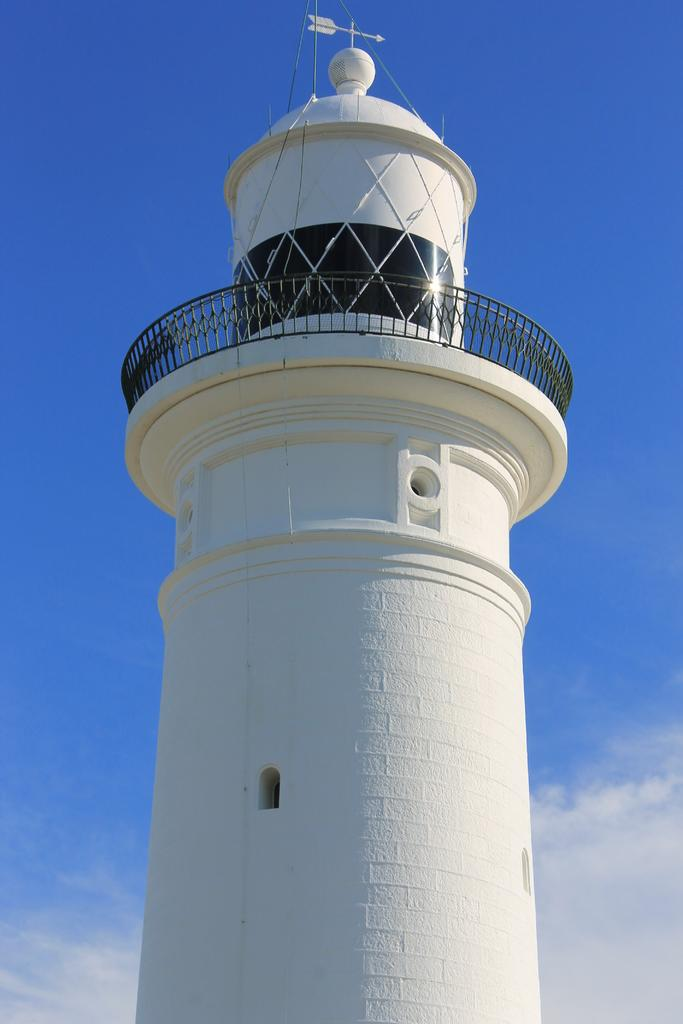What type of structure is present in the image? There is a white color lighthouse in the image. What color is the sky in the image? The sky is blue in the image. How many chairs are placed around the lighthouse in the image? There is no mention of chairs in the image, so we cannot determine the number of chairs present. 